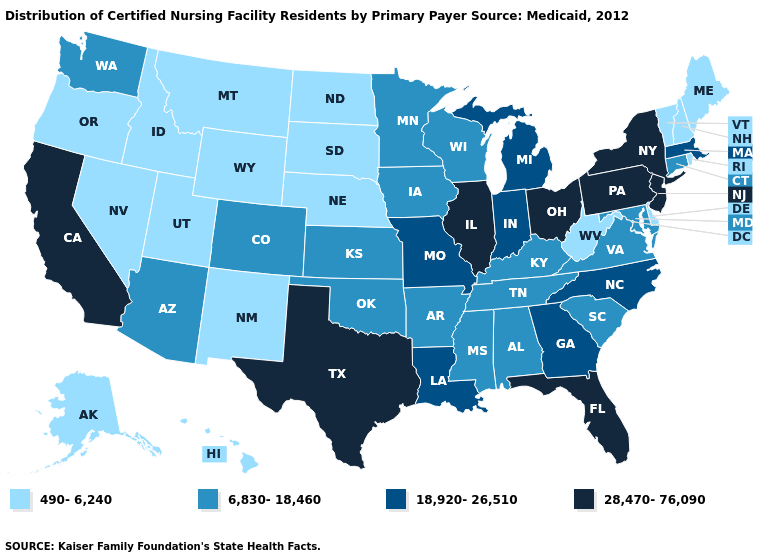What is the value of West Virginia?
Concise answer only. 490-6,240. Does Pennsylvania have the highest value in the USA?
Give a very brief answer. Yes. Among the states that border Florida , does Alabama have the lowest value?
Answer briefly. Yes. Name the states that have a value in the range 28,470-76,090?
Short answer required. California, Florida, Illinois, New Jersey, New York, Ohio, Pennsylvania, Texas. Name the states that have a value in the range 490-6,240?
Quick response, please. Alaska, Delaware, Hawaii, Idaho, Maine, Montana, Nebraska, Nevada, New Hampshire, New Mexico, North Dakota, Oregon, Rhode Island, South Dakota, Utah, Vermont, West Virginia, Wyoming. Among the states that border New Mexico , does Utah have the highest value?
Quick response, please. No. What is the highest value in the USA?
Concise answer only. 28,470-76,090. Name the states that have a value in the range 490-6,240?
Be succinct. Alaska, Delaware, Hawaii, Idaho, Maine, Montana, Nebraska, Nevada, New Hampshire, New Mexico, North Dakota, Oregon, Rhode Island, South Dakota, Utah, Vermont, West Virginia, Wyoming. Among the states that border Utah , does Arizona have the lowest value?
Concise answer only. No. Which states have the lowest value in the South?
Quick response, please. Delaware, West Virginia. Name the states that have a value in the range 6,830-18,460?
Quick response, please. Alabama, Arizona, Arkansas, Colorado, Connecticut, Iowa, Kansas, Kentucky, Maryland, Minnesota, Mississippi, Oklahoma, South Carolina, Tennessee, Virginia, Washington, Wisconsin. Does Ohio have the lowest value in the MidWest?
Give a very brief answer. No. Name the states that have a value in the range 18,920-26,510?
Give a very brief answer. Georgia, Indiana, Louisiana, Massachusetts, Michigan, Missouri, North Carolina. What is the value of Maryland?
Short answer required. 6,830-18,460. Does the map have missing data?
Concise answer only. No. 